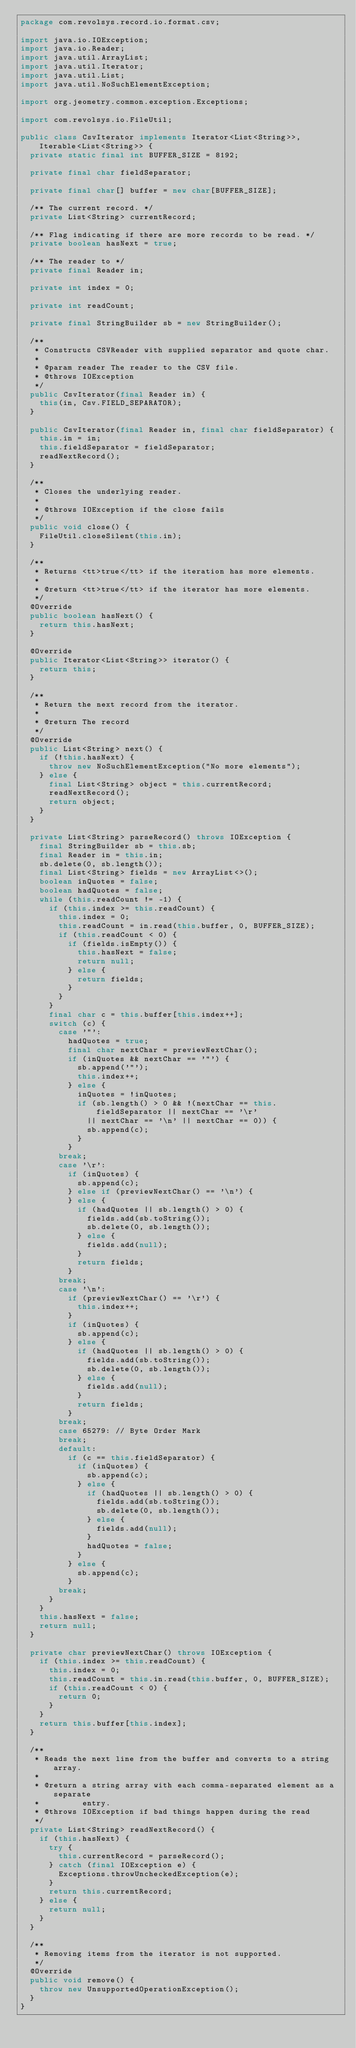Convert code to text. <code><loc_0><loc_0><loc_500><loc_500><_Java_>package com.revolsys.record.io.format.csv;

import java.io.IOException;
import java.io.Reader;
import java.util.ArrayList;
import java.util.Iterator;
import java.util.List;
import java.util.NoSuchElementException;

import org.jeometry.common.exception.Exceptions;

import com.revolsys.io.FileUtil;

public class CsvIterator implements Iterator<List<String>>, Iterable<List<String>> {
  private static final int BUFFER_SIZE = 8192;

  private final char fieldSeparator;

  private final char[] buffer = new char[BUFFER_SIZE];

  /** The current record. */
  private List<String> currentRecord;

  /** Flag indicating if there are more records to be read. */
  private boolean hasNext = true;

  /** The reader to */
  private final Reader in;

  private int index = 0;

  private int readCount;

  private final StringBuilder sb = new StringBuilder();

  /**
   * Constructs CSVReader with supplied separator and quote char.
   *
   * @param reader The reader to the CSV file.
   * @throws IOException
   */
  public CsvIterator(final Reader in) {
    this(in, Csv.FIELD_SEPARATOR);
  }

  public CsvIterator(final Reader in, final char fieldSeparator) {
    this.in = in;
    this.fieldSeparator = fieldSeparator;
    readNextRecord();
  }

  /**
   * Closes the underlying reader.
   *
   * @throws IOException if the close fails
   */
  public void close() {
    FileUtil.closeSilent(this.in);
  }

  /**
   * Returns <tt>true</tt> if the iteration has more elements.
   *
   * @return <tt>true</tt> if the iterator has more elements.
   */
  @Override
  public boolean hasNext() {
    return this.hasNext;
  }

  @Override
  public Iterator<List<String>> iterator() {
    return this;
  }

  /**
   * Return the next record from the iterator.
   *
   * @return The record
   */
  @Override
  public List<String> next() {
    if (!this.hasNext) {
      throw new NoSuchElementException("No more elements");
    } else {
      final List<String> object = this.currentRecord;
      readNextRecord();
      return object;
    }
  }

  private List<String> parseRecord() throws IOException {
    final StringBuilder sb = this.sb;
    final Reader in = this.in;
    sb.delete(0, sb.length());
    final List<String> fields = new ArrayList<>();
    boolean inQuotes = false;
    boolean hadQuotes = false;
    while (this.readCount != -1) {
      if (this.index >= this.readCount) {
        this.index = 0;
        this.readCount = in.read(this.buffer, 0, BUFFER_SIZE);
        if (this.readCount < 0) {
          if (fields.isEmpty()) {
            this.hasNext = false;
            return null;
          } else {
            return fields;
          }
        }
      }
      final char c = this.buffer[this.index++];
      switch (c) {
        case '"':
          hadQuotes = true;
          final char nextChar = previewNextChar();
          if (inQuotes && nextChar == '"') {
            sb.append('"');
            this.index++;
          } else {
            inQuotes = !inQuotes;
            if (sb.length() > 0 && !(nextChar == this.fieldSeparator || nextChar == '\r'
              || nextChar == '\n' || nextChar == 0)) {
              sb.append(c);
            }
          }
        break;
        case '\r':
          if (inQuotes) {
            sb.append(c);
          } else if (previewNextChar() == '\n') {
          } else {
            if (hadQuotes || sb.length() > 0) {
              fields.add(sb.toString());
              sb.delete(0, sb.length());
            } else {
              fields.add(null);
            }
            return fields;
          }
        break;
        case '\n':
          if (previewNextChar() == '\r') {
            this.index++;
          }
          if (inQuotes) {
            sb.append(c);
          } else {
            if (hadQuotes || sb.length() > 0) {
              fields.add(sb.toString());
              sb.delete(0, sb.length());
            } else {
              fields.add(null);
            }
            return fields;
          }
        break;
        case 65279: // Byte Order Mark
        break;
        default:
          if (c == this.fieldSeparator) {
            if (inQuotes) {
              sb.append(c);
            } else {
              if (hadQuotes || sb.length() > 0) {
                fields.add(sb.toString());
                sb.delete(0, sb.length());
              } else {
                fields.add(null);
              }
              hadQuotes = false;
            }
          } else {
            sb.append(c);
          }
        break;
      }
    }
    this.hasNext = false;
    return null;
  }

  private char previewNextChar() throws IOException {
    if (this.index >= this.readCount) {
      this.index = 0;
      this.readCount = this.in.read(this.buffer, 0, BUFFER_SIZE);
      if (this.readCount < 0) {
        return 0;
      }
    }
    return this.buffer[this.index];
  }

  /**
   * Reads the next line from the buffer and converts to a string array.
   *
   * @return a string array with each comma-separated element as a separate
   *         entry.
   * @throws IOException if bad things happen during the read
   */
  private List<String> readNextRecord() {
    if (this.hasNext) {
      try {
        this.currentRecord = parseRecord();
      } catch (final IOException e) {
        Exceptions.throwUncheckedException(e);
      }
      return this.currentRecord;
    } else {
      return null;
    }
  }

  /**
   * Removing items from the iterator is not supported.
   */
  @Override
  public void remove() {
    throw new UnsupportedOperationException();
  }
}
</code> 